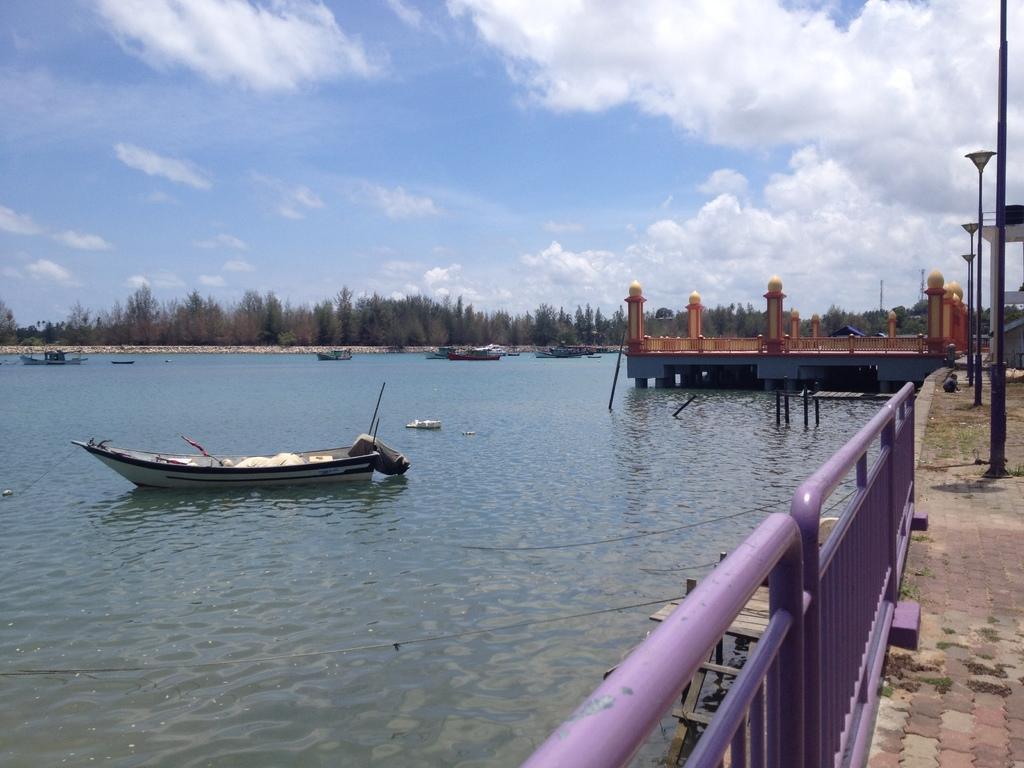Please provide a concise description of this image. In this image I can see a lake of water and few boats in it. In the background I can see number of trees, street lights and sky with clouds. 